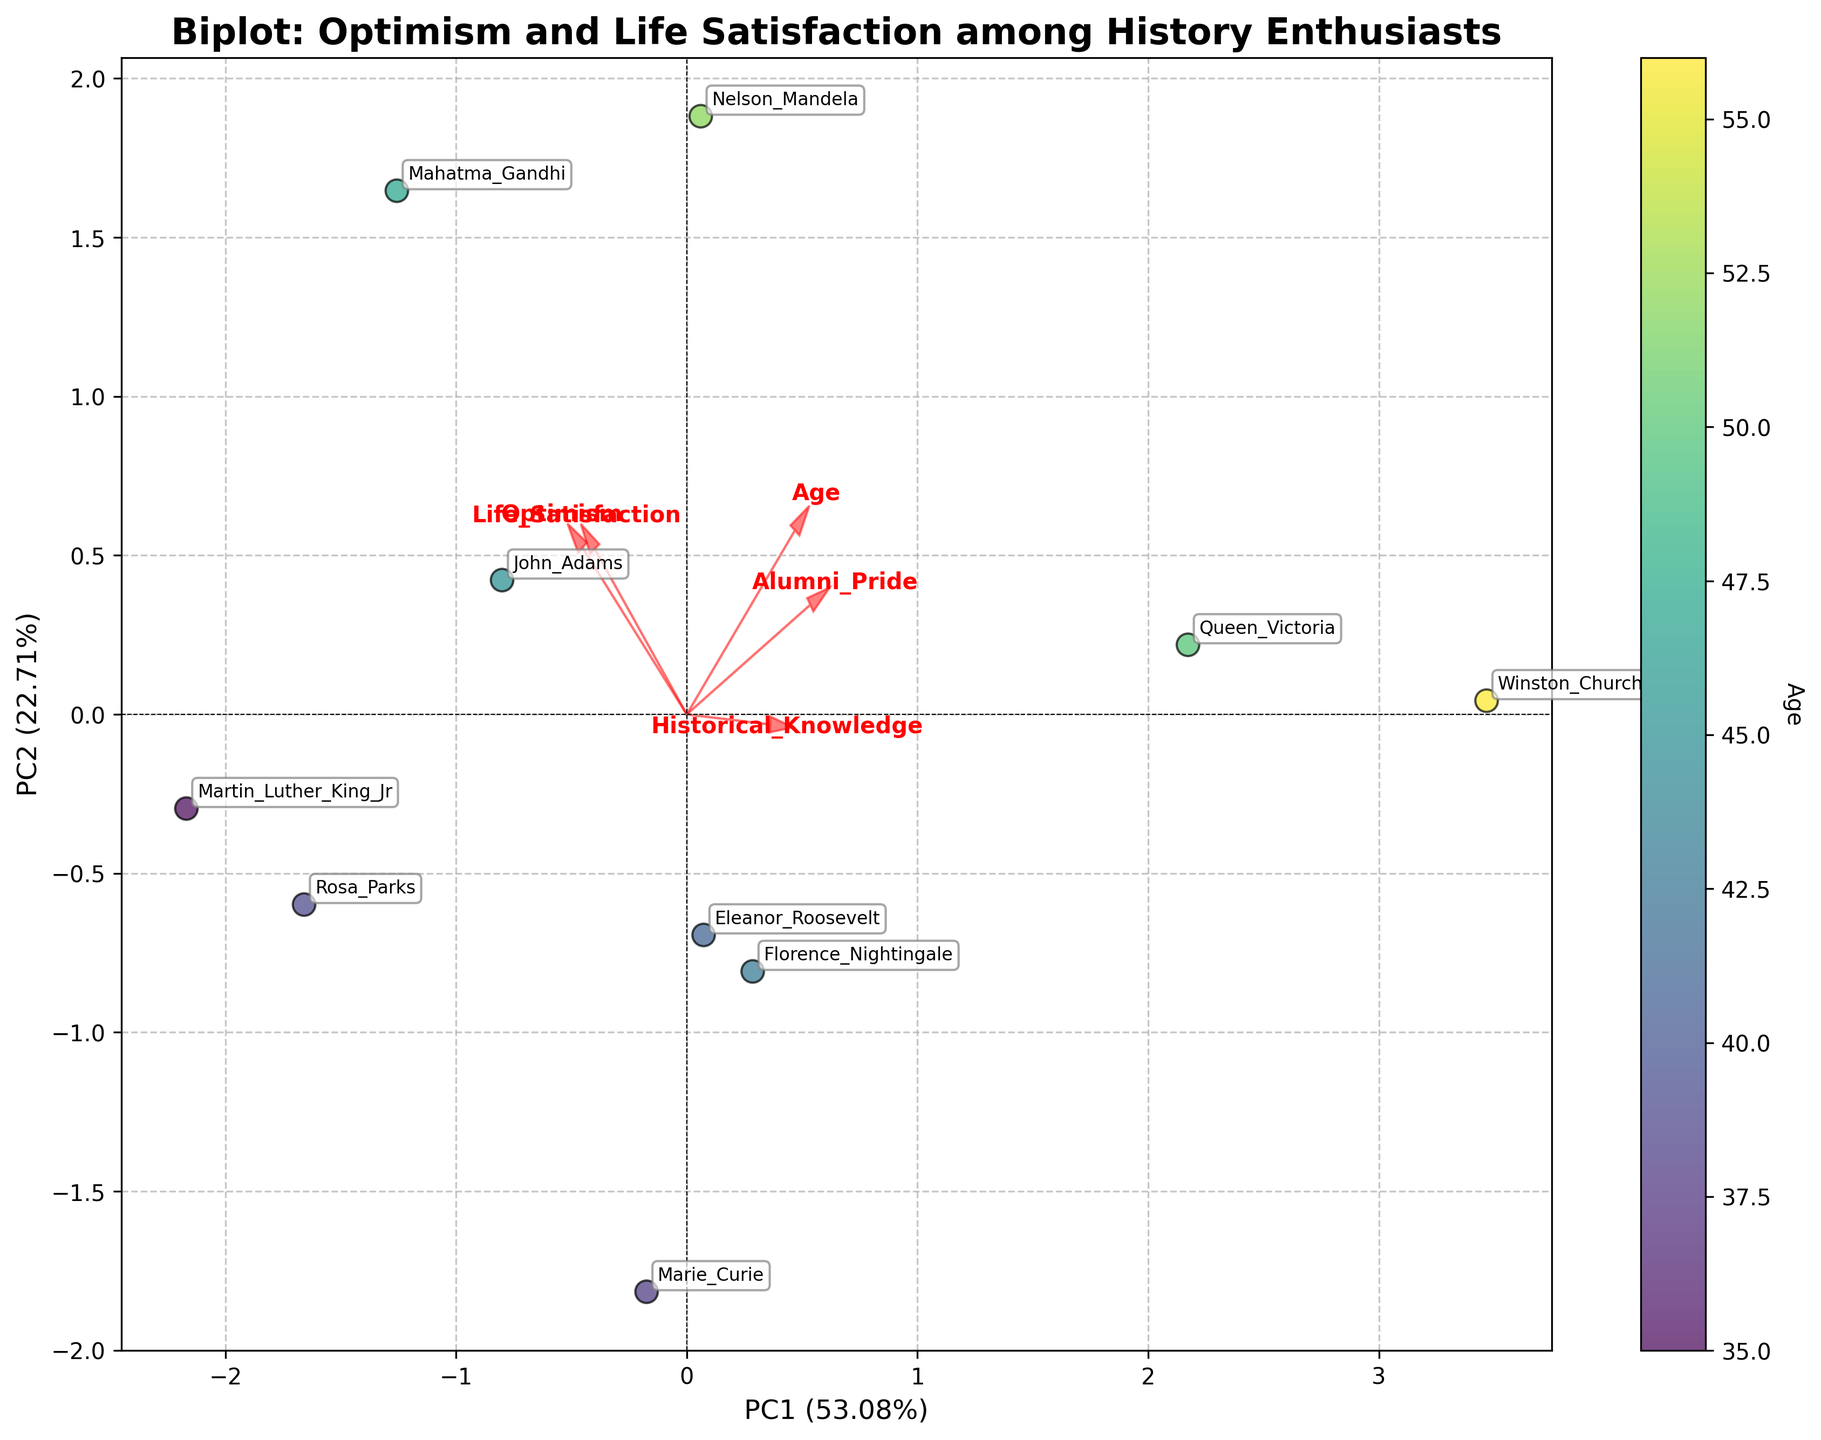How many data points are represented in the plot? There is one data point for each individual listed in the table. We have 10 individuals, so there are 10 data points in total.
Answer: 10 What variable is represented by the arrows labeled "Optimism" and "Life_Satisfaction"? The arrows represent the principal components of these variables after the PCA transformation. "Optimism" and "Life_Satisfaction" are two of the original variables that contributed to the PCA results.
Answer: Optimism and Life_Satisfaction Which individual has the highest level of optimism according to the plot? By referring to both the table and the annotations near the data points, we see that Mahatma Gandhi has the highest optimism score of 10.
Answer: Mahatma Gandhi Which axis in the plot explains the largest percentage of variance? The percentage of variance explained by each principal component (PC) is given on the axis labels. The x-axis (PC1) explains the larger amount of 52% compared to 27% for the y-axis (PC2).
Answer: The x-axis (PC1) What is the relationship between "Optimism" and "Life_Satisfaction" according to the plot? The direction of the arrows representing "Optimism" and "Life_Satisfaction" suggests that they are positively correlated. Because they point in approximately the same direction in the biplot, an increase in one likely suggests an increase in the other.
Answer: Positively correlated Which individual is labeled closest to the arrow representing "Historical_Knowledge"? The individual closest to the "Historical_Knowledge" arrow would be Winston Churchill based on the projection of data points onto the direction of the arrow.
Answer: Winston Churchill What does the color of the data points represent in the figure? The color gradient of the data points represents the age of the individuals. This can be determined from the colorbar labeled 'Age'.
Answer: Age What is the median age of the individuals depicted in the plot? The ages listed are 45, 38, 52, 41, 56, 39, 47, 43, 35, and 50. When sorted (35, 38, 39, 41, 43, 45, 47, 50, 52, 56), the median age is the average of the 5th and 6th elements: (43 + 45)/2 = 44.
Answer: 44 Which variable seems to have the strongest influence on the first principal component (PC1)? The length and direction of the arrow in the PC1 direction can indicate influence. The variable with the longest projection along PC1 would be "Optimism".
Answer: Optimism What historical figure’s life satisfaction score is aligned with the highest value along the y-axis (PC2)? By examining the y-axis (PC2) and annotations, Nelson Mandela and Martin Luther King Jr. have the highest values aligning with the top of the plot, each having a life satisfaction score of 9.
Answer: Nelson Mandela/Martin Luther King Jr 